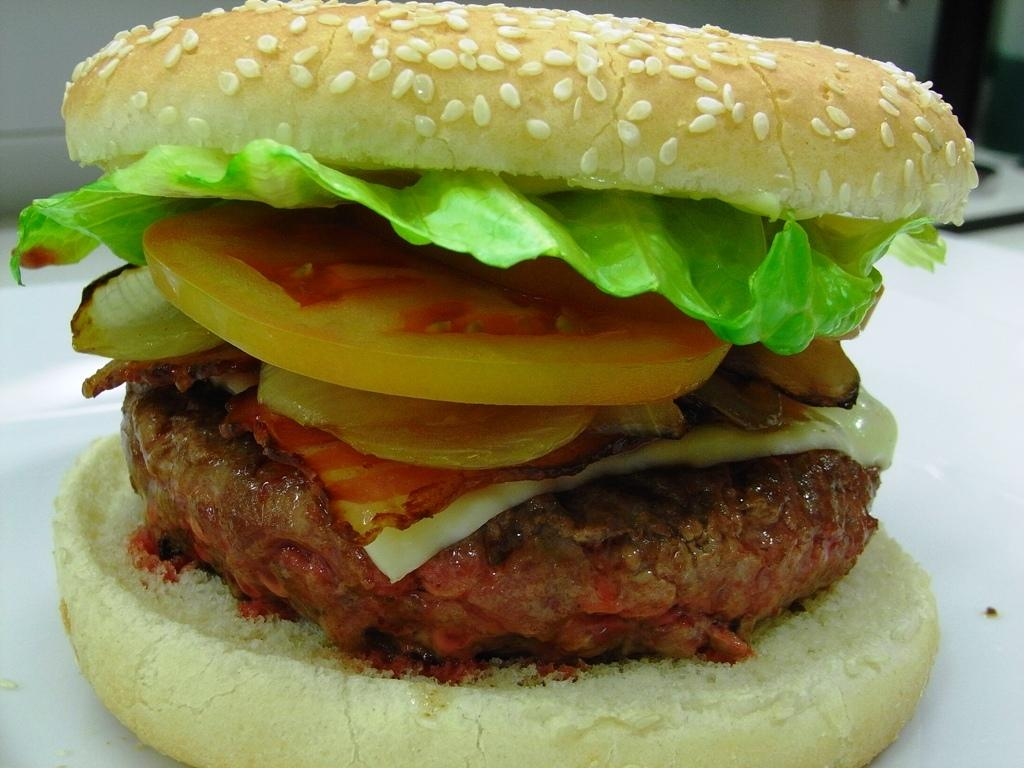What type of food is shown in the image? There is a burger in the image. On what surface is the burger placed? The burger is on a white table. What type of snake can be seen slithering on the burger in the image? There is no snake present in the image; it only shows a burger on a white table. 